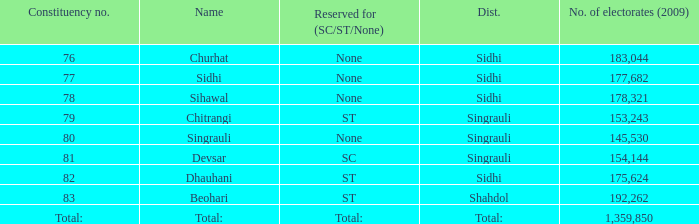What is the district with 79 constituency number? Singrauli. 